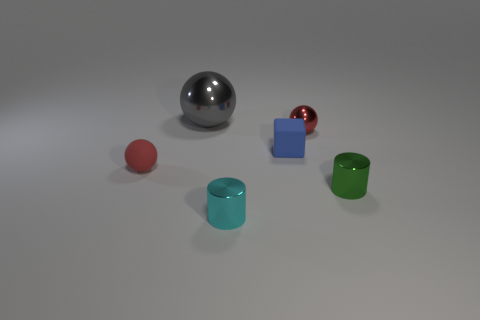What is the shape of the tiny red object that is the same material as the green object?
Make the answer very short. Sphere. There is a small cyan object; what shape is it?
Provide a succinct answer. Cylinder. What is the color of the small metallic object that is on the left side of the green metallic cylinder and in front of the tiny block?
Provide a succinct answer. Cyan. The rubber object that is the same size as the rubber ball is what shape?
Offer a terse response. Cube. Is there another large thing that has the same shape as the green object?
Keep it short and to the point. No. Do the small green cylinder and the sphere that is in front of the blue object have the same material?
Your answer should be very brief. No. What color is the shiny thing in front of the metallic cylinder behind the cylinder in front of the green shiny cylinder?
Offer a terse response. Cyan. What material is the cyan object that is the same size as the green metal cylinder?
Provide a short and direct response. Metal. What number of green cylinders are the same material as the small green object?
Keep it short and to the point. 0. Do the shiny cylinder that is behind the cyan object and the red object to the left of the large gray thing have the same size?
Offer a terse response. Yes. 